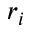Convert formula to latex. <formula><loc_0><loc_0><loc_500><loc_500>r _ { i }</formula> 